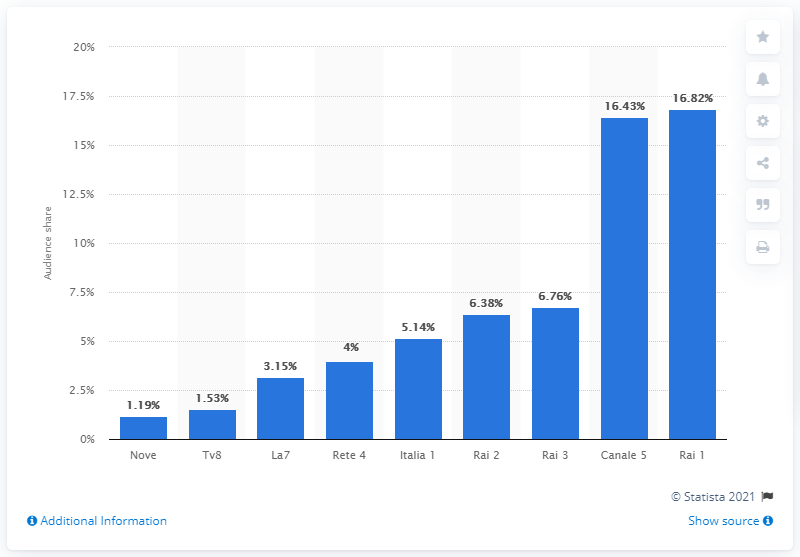Point out several critical features in this image. Rai 1 has the highest audience share among all channels. The average between the two topmost channels is 16.62. 